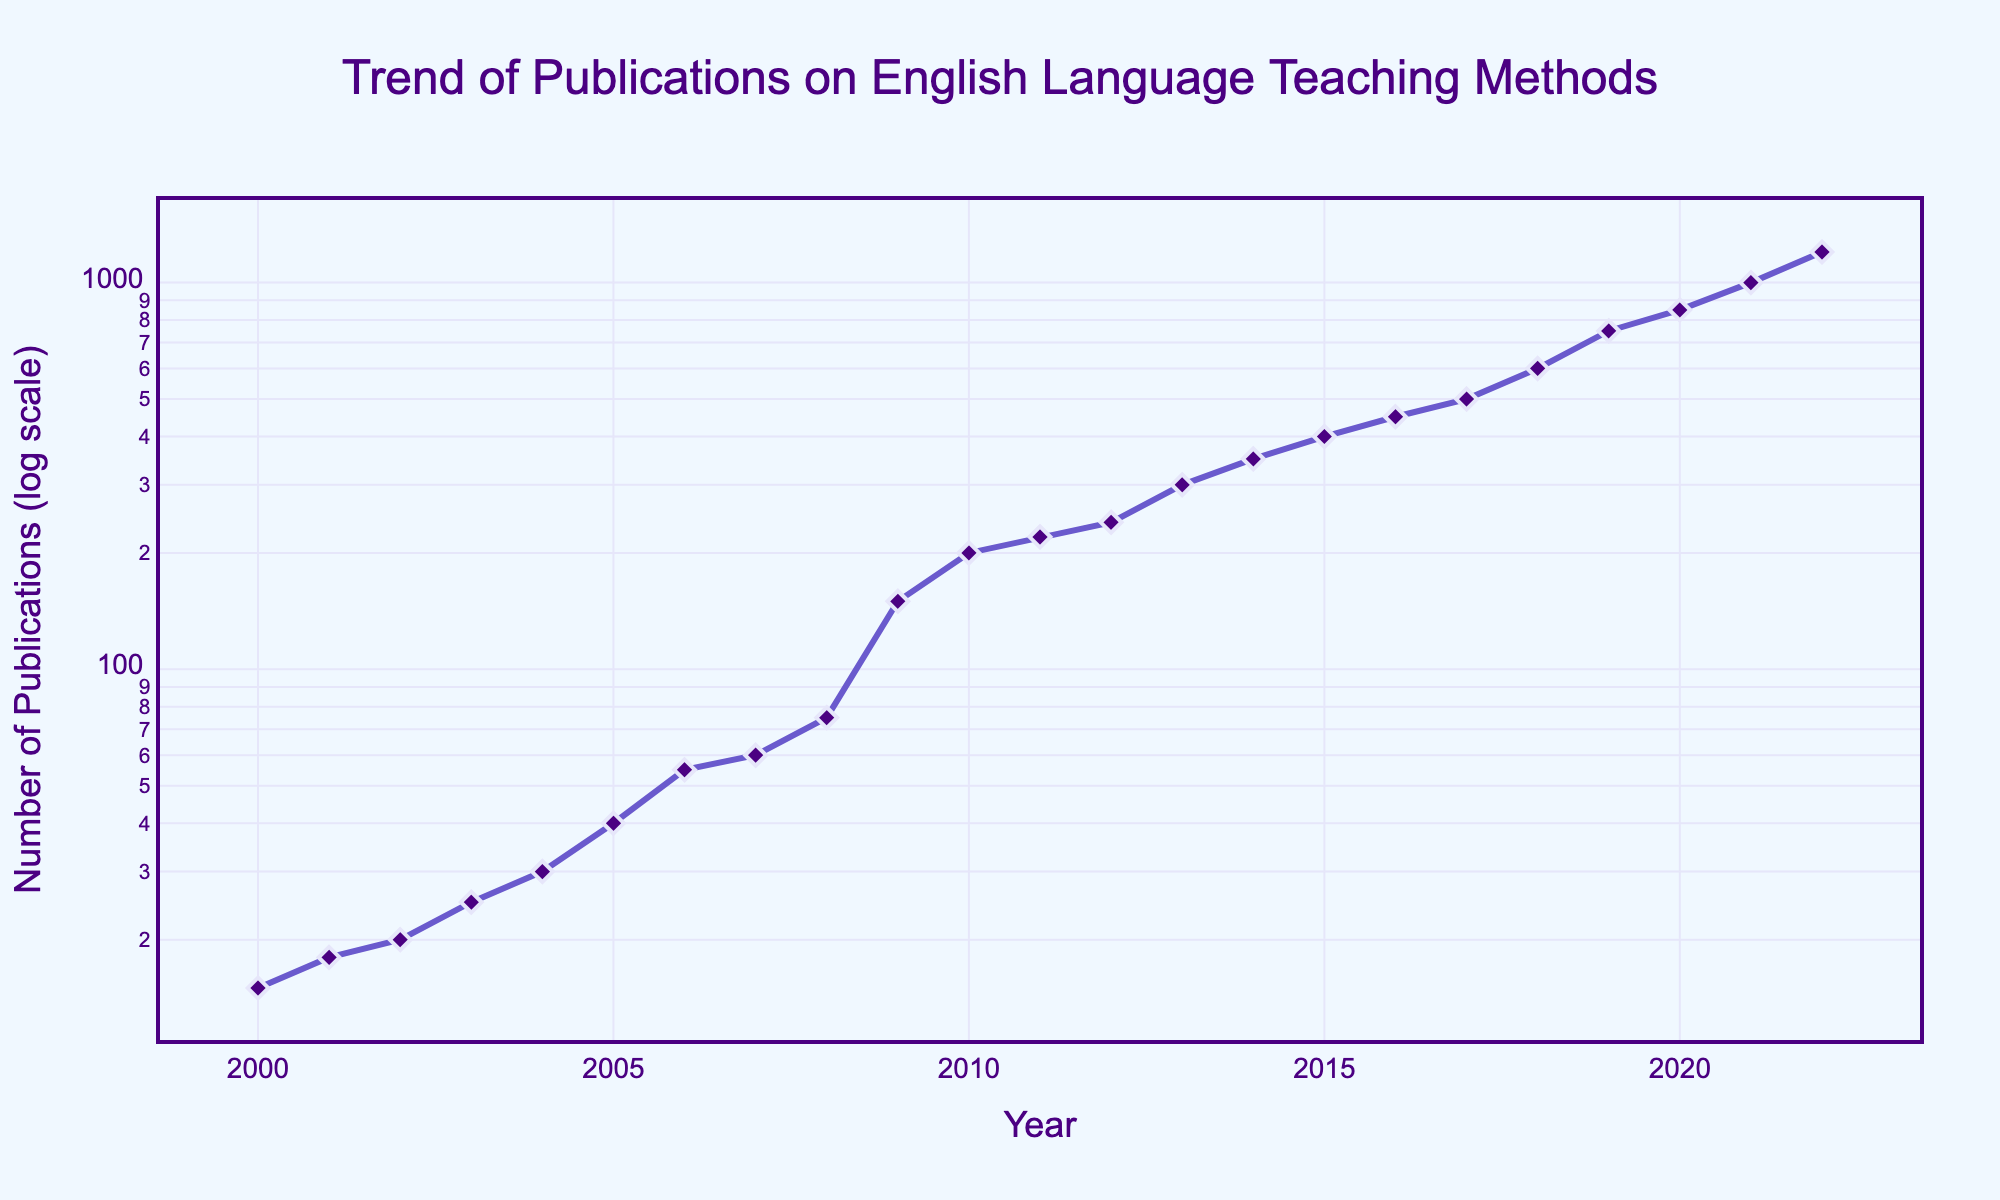What is the title of the plot? The title of the plot is usually displayed prominently at the top of the chart. In this case, the title is 'Trend of Publications on English Language Teaching Methods.'
Answer: Trend of Publications on English Language Teaching Methods What is the value of publications in the year 2010? To find the number of publications in a specific year, locate the year on the x-axis and find the corresponding value on the y-axis. In this case, for 2010, it shows 200 publications.
Answer: 200 Between which years did the number of publications first exceed 1000? Look for the point on the line where the y-axis value first surpasses 1000, then identify the corresponding years. This occurs between the years 2020 and 2021.
Answer: 2020 and 2021 What is the overall trend from 2000 to 2022? Observe the general direction of the line from the start year to the end year. The line shows an increasing trend, indicating a growth in publications over time.
Answer: Increasing How does the rate of increase in publications change around 2009? Compare the slope (steepness) of the line before and after 2009. Around 2009, the line becomes significantly steeper, indicating a more rapid increase in the number of publications.
Answer: Becomes more rapid By what factor did the number of publications grow from 2000 to 2022? Use the values at 2000 and 2022 (15 and 1200 respectively). Calculate the factor by dividing the latter by the former: 1200 / 15 = 80.
Answer: Approximately 80 Which decade showed the fastest growth in the number of publications? Compare the slopes of the line for each decade by examining their steepness. The decade from 2010 to 2020 shows the fastest growth since the line is steepest in this period.
Answer: 2010 to 2020 At what year do the publications appear to grow more than expected based on the previous trend? Look for any significant jumps in the number of publications as compared to the general trend. Around 2009, the publications grow more than expected as the line becomes significantly steeper.
Answer: 2009 What is the approximate number of publications in the year 2018? Find the year 2018 on the x-axis and trace it up to intersect with the line, then read off the corresponding value on the y-axis, which is approximately 600.
Answer: 600 How many data points are there in the plot? Count the individual markers on the line plot. The number of data points corresponds to the number of years listed, which is 23.
Answer: 23 